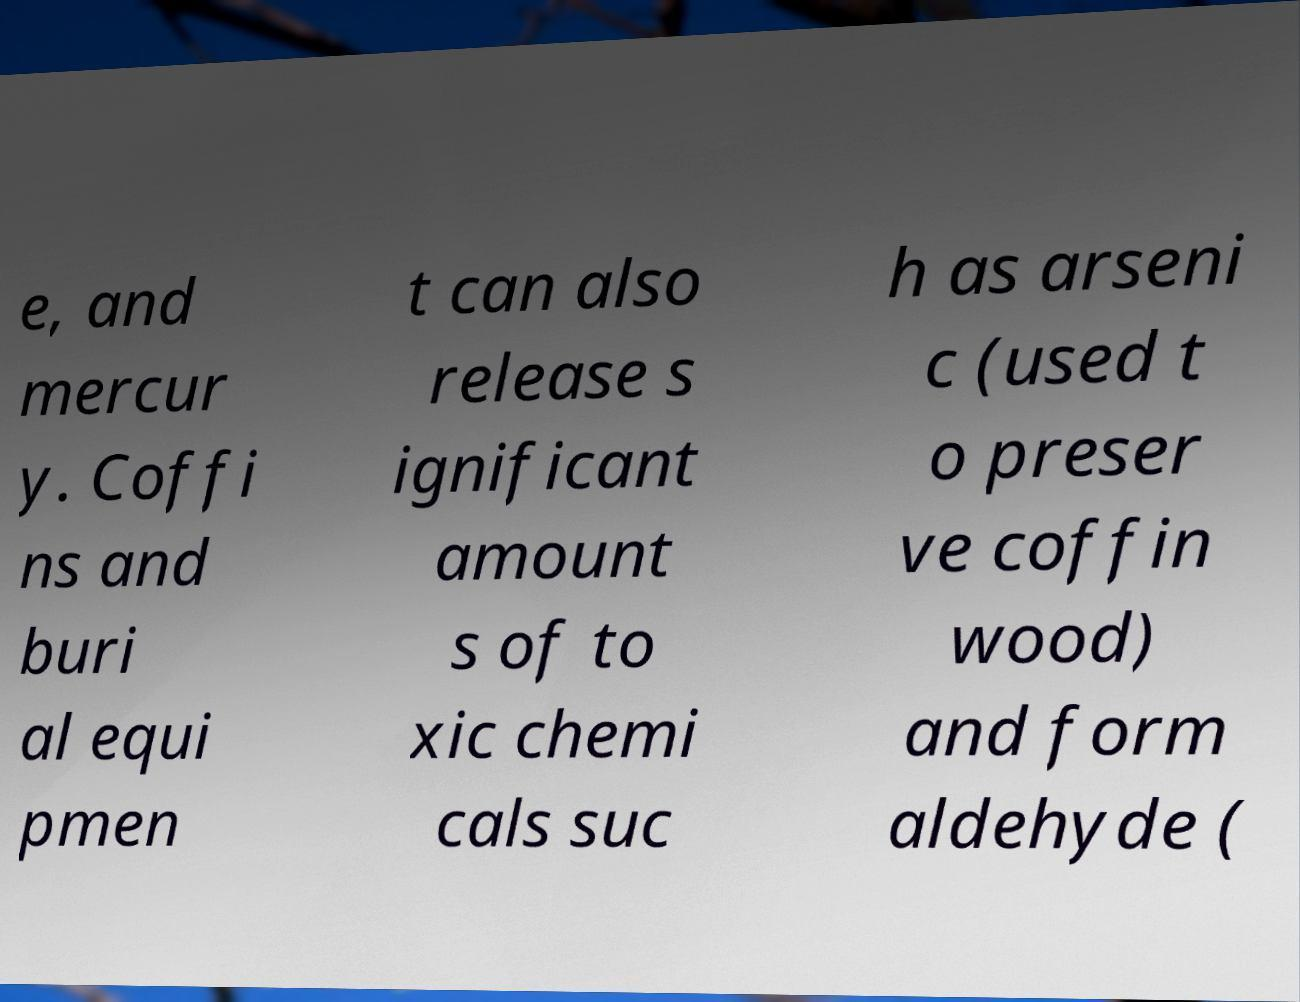Could you extract and type out the text from this image? e, and mercur y. Coffi ns and buri al equi pmen t can also release s ignificant amount s of to xic chemi cals suc h as arseni c (used t o preser ve coffin wood) and form aldehyde ( 